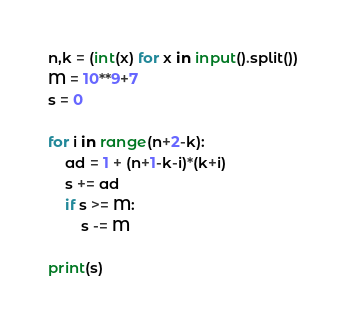Convert code to text. <code><loc_0><loc_0><loc_500><loc_500><_Python_>n,k = (int(x) for x in input().split())
M = 10**9+7
s = 0

for i in range(n+2-k):
    ad = 1 + (n+1-k-i)*(k+i)
    s += ad
    if s >= M:
        s -= M
        
print(s)</code> 